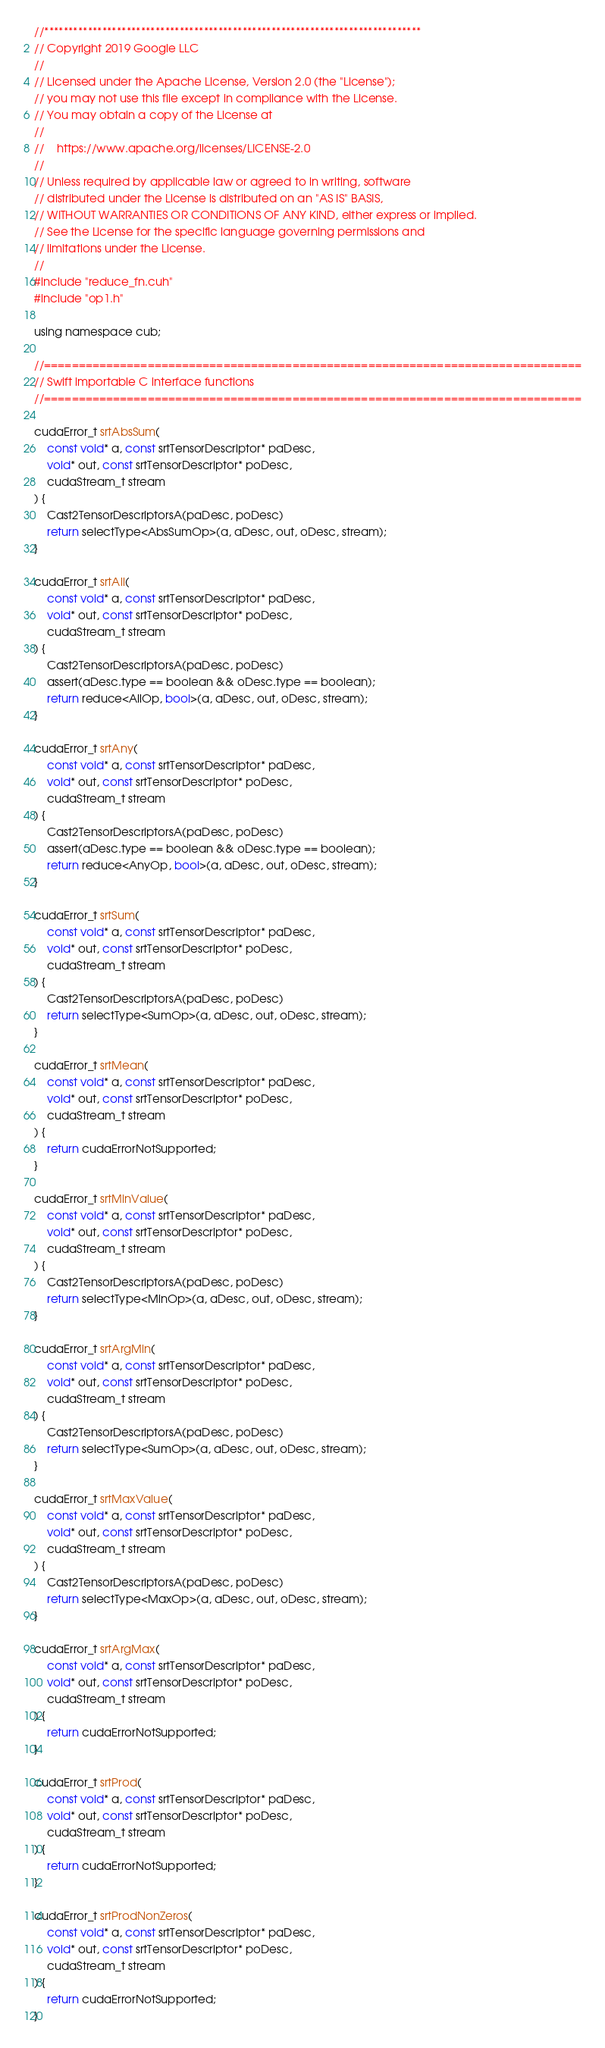Convert code to text. <code><loc_0><loc_0><loc_500><loc_500><_Cuda_>//******************************************************************************
// Copyright 2019 Google LLC
//
// Licensed under the Apache License, Version 2.0 (the "License");
// you may not use this file except in compliance with the License.
// You may obtain a copy of the License at
//
//    https://www.apache.org/licenses/LICENSE-2.0
//
// Unless required by applicable law or agreed to in writing, software
// distributed under the License is distributed on an "AS IS" BASIS,
// WITHOUT WARRANTIES OR CONDITIONS OF ANY KIND, either express or implied.
// See the License for the specific language governing permissions and
// limitations under the License.
//
#include "reduce_fn.cuh"
#include "op1.h"

using namespace cub;

//==============================================================================
// Swift importable C interface functions
//==============================================================================

cudaError_t srtAbsSum(
    const void* a, const srtTensorDescriptor* paDesc,
    void* out, const srtTensorDescriptor* poDesc,
    cudaStream_t stream
) {
    Cast2TensorDescriptorsA(paDesc, poDesc)
    return selectType<AbsSumOp>(a, aDesc, out, oDesc, stream);
}

cudaError_t srtAll(
    const void* a, const srtTensorDescriptor* paDesc,
    void* out, const srtTensorDescriptor* poDesc,
    cudaStream_t stream
) {
    Cast2TensorDescriptorsA(paDesc, poDesc)
    assert(aDesc.type == boolean && oDesc.type == boolean);
    return reduce<AllOp, bool>(a, aDesc, out, oDesc, stream);
}

cudaError_t srtAny(
    const void* a, const srtTensorDescriptor* paDesc,
    void* out, const srtTensorDescriptor* poDesc,
    cudaStream_t stream
) {
    Cast2TensorDescriptorsA(paDesc, poDesc)
    assert(aDesc.type == boolean && oDesc.type == boolean);
    return reduce<AnyOp, bool>(a, aDesc, out, oDesc, stream);
}

cudaError_t srtSum(
    const void* a, const srtTensorDescriptor* paDesc,
    void* out, const srtTensorDescriptor* poDesc,
    cudaStream_t stream
) {
    Cast2TensorDescriptorsA(paDesc, poDesc)
    return selectType<SumOp>(a, aDesc, out, oDesc, stream);
}

cudaError_t srtMean(
    const void* a, const srtTensorDescriptor* paDesc,
    void* out, const srtTensorDescriptor* poDesc,
    cudaStream_t stream
) {
    return cudaErrorNotSupported;
}

cudaError_t srtMinValue(
    const void* a, const srtTensorDescriptor* paDesc,
    void* out, const srtTensorDescriptor* poDesc,
    cudaStream_t stream
) {
    Cast2TensorDescriptorsA(paDesc, poDesc)
    return selectType<MinOp>(a, aDesc, out, oDesc, stream);
}

cudaError_t srtArgMin(
    const void* a, const srtTensorDescriptor* paDesc,
    void* out, const srtTensorDescriptor* poDesc,
    cudaStream_t stream
) {
    Cast2TensorDescriptorsA(paDesc, poDesc)
    return selectType<SumOp>(a, aDesc, out, oDesc, stream);
}

cudaError_t srtMaxValue(
    const void* a, const srtTensorDescriptor* paDesc,
    void* out, const srtTensorDescriptor* poDesc,
    cudaStream_t stream
) {
    Cast2TensorDescriptorsA(paDesc, poDesc)
    return selectType<MaxOp>(a, aDesc, out, oDesc, stream);
}

cudaError_t srtArgMax(
    const void* a, const srtTensorDescriptor* paDesc,
    void* out, const srtTensorDescriptor* poDesc,
    cudaStream_t stream
) {
    return cudaErrorNotSupported;
}

cudaError_t srtProd(
    const void* a, const srtTensorDescriptor* paDesc,
    void* out, const srtTensorDescriptor* poDesc,
    cudaStream_t stream
) {
    return cudaErrorNotSupported;
}

cudaError_t srtProdNonZeros(
    const void* a, const srtTensorDescriptor* paDesc,
    void* out, const srtTensorDescriptor* poDesc,
    cudaStream_t stream
) {
    return cudaErrorNotSupported;
}
</code> 